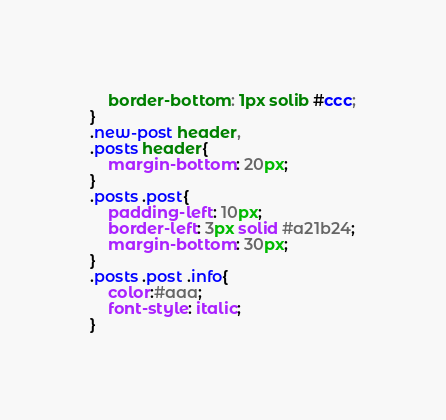Convert code to text. <code><loc_0><loc_0><loc_500><loc_500><_CSS_>	border-bottom: 1px solib #ccc;
}
.new-post header,
.posts header{
	margin-bottom: 20px;
}
.posts .post{
	padding-left: 10px;
	border-left: 3px solid #a21b24;
	margin-bottom: 30px;
}
.posts .post .info{
	color:#aaa;
	font-style: italic;
}</code> 